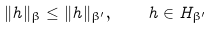<formula> <loc_0><loc_0><loc_500><loc_500>\| h \| _ { \beta } \leq \| h \| _ { \beta ^ { \prime } } , \quad h \in H _ { \beta ^ { \prime } }</formula> 